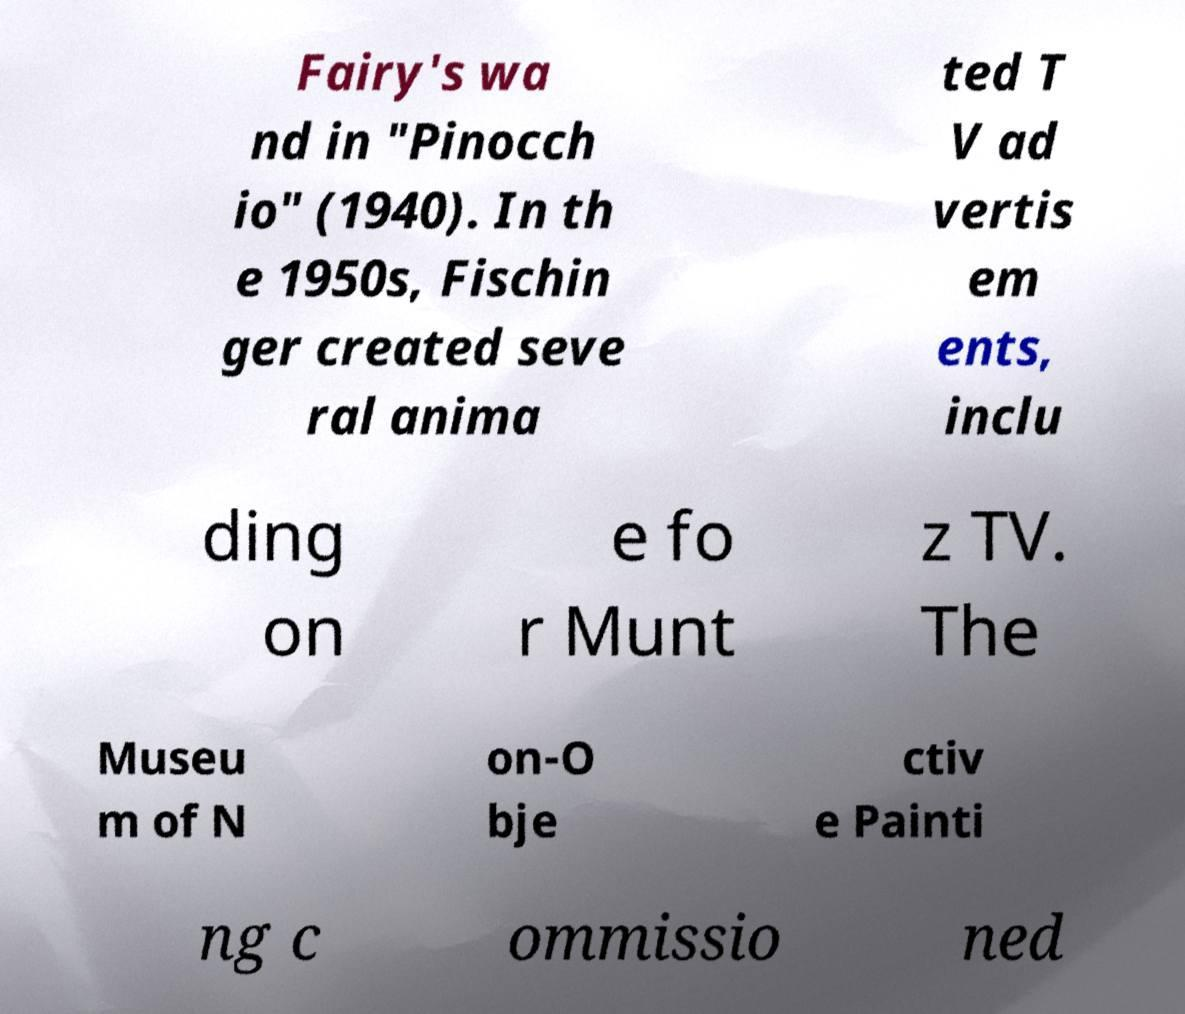For documentation purposes, I need the text within this image transcribed. Could you provide that? Fairy's wa nd in "Pinocch io" (1940). In th e 1950s, Fischin ger created seve ral anima ted T V ad vertis em ents, inclu ding on e fo r Munt z TV. The Museu m of N on-O bje ctiv e Painti ng c ommissio ned 